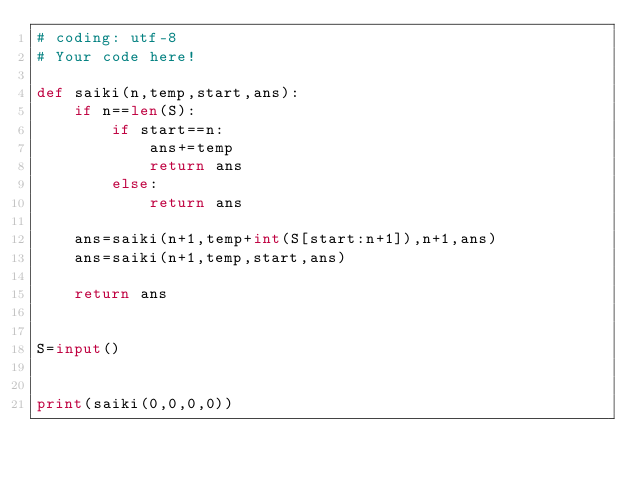<code> <loc_0><loc_0><loc_500><loc_500><_Python_># coding: utf-8
# Your code here!

def saiki(n,temp,start,ans):
    if n==len(S):
        if start==n:
            ans+=temp
            return ans
        else:
            return ans
    
    ans=saiki(n+1,temp+int(S[start:n+1]),n+1,ans)
    ans=saiki(n+1,temp,start,ans)
    
    return ans


S=input()


print(saiki(0,0,0,0))

</code> 